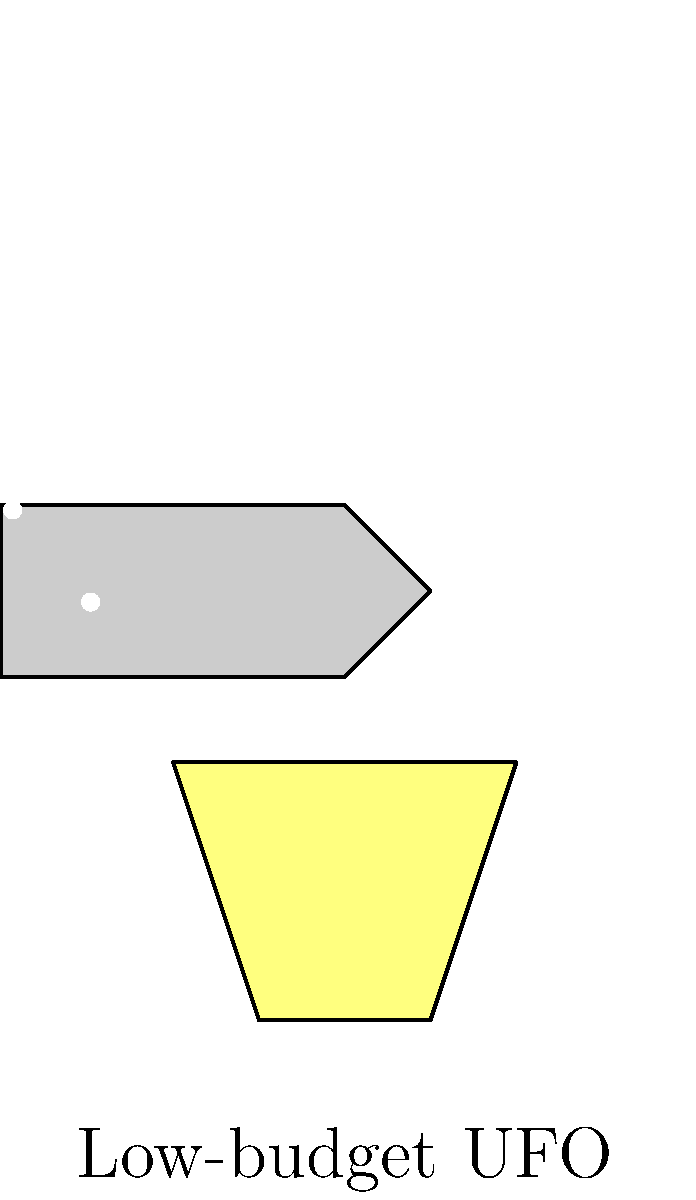In recreating a classic B-movie UFO abduction scene using vector illustrations, which key elements should be included to capture the essence of low-budget special effects? To recreate a classic B-movie UFO abduction scene using vector illustrations, we need to consider several key elements that capture the essence of low-budget special effects:

1. Simplified Shapes: Use basic geometric shapes to create the UFO and other elements. In this case, we used a combination of rectangles and triangles for the spaceship.

2. Limited Color Palette: Stick to a few colors to mimic the limited resources of low-budget films. Here, we used gray for the spaceship and a pale yellow for the beam.

3. Beam Effect: Create a simple beam effect using a trapezoid shape, which is a common representation in B-movies.

4. Starry Background: Add small white dots to represent stars, creating a simple space backdrop.

5. Flat Design: Avoid complex shading or gradients, keeping the design flat and two-dimensional.

6. Clear Outlines: Use distinct outlines to define the shapes, enhancing the hand-drawn feel of low-budget effects.

7. Symmetry: Maintain symmetry in the design, as it's easier to create and aligns with the aesthetic of many B-movie effects.

8. Text Element: Include a simple text label to mimic the often-used explanatory text in B-movies.

By incorporating these elements, we create a vector illustration that captures the charm and limitations of low-budget special effects, perfect for analyzing and drawing inspiration from cult classics and B-movies.
Answer: Simplified shapes, limited colors, beam effect, starry background, flat design, clear outlines, symmetry, and text element. 